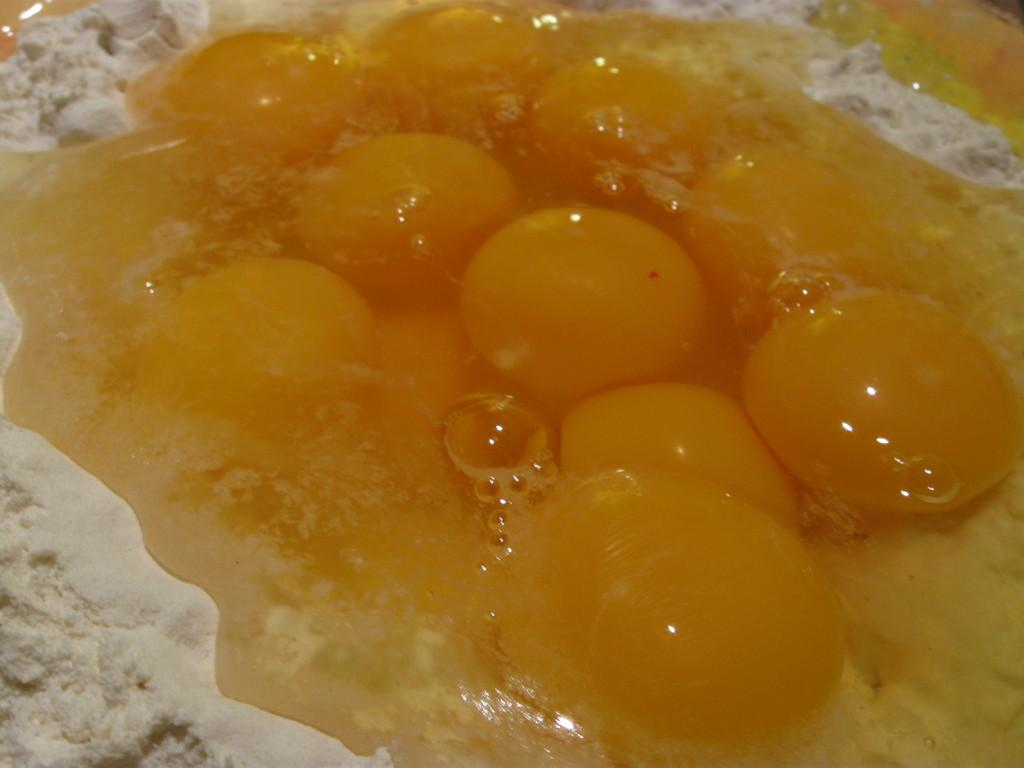What is the primary substance visible in the image? There is cream-colored flour in the image. What is the appearance of the liquid on the flour? There is a yellow-colored liquid on the flour. Can you see a yak grazing on the land in the image? There is no yak or land present in the image; it only features cream-colored flour and a yellow-colored liquid. 